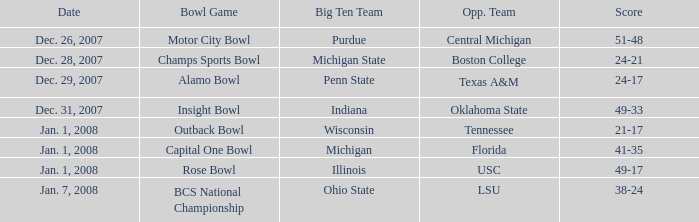What bowl game was played on Dec. 26, 2007? Motor City Bowl. 